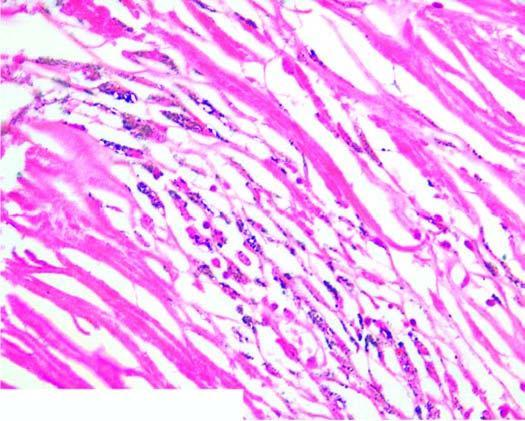does polarising microscopy in photomicrograph on right show bright fibres of silica?
Answer the question using a single word or phrase. Yes 